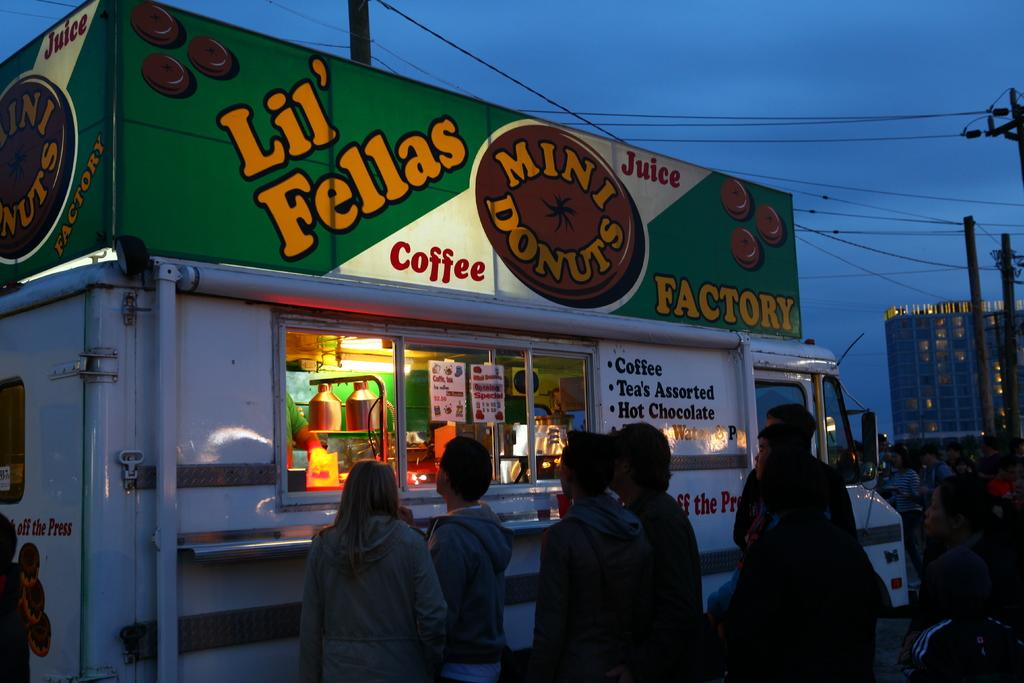How many people are in the group that is visible in the image? There is a group of people standing in the image, but the exact number cannot be determined from the provided facts. What type of vehicle is in the image? There is a vehicle in the image, but the specific type cannot be determined from the provided facts. What are the banners and posters used for in the image? Banners and posters are present in the image, but their purpose cannot be determined from the provided facts. What are the cans used for in the image? Cans are in the image, but their purpose cannot be determined from the provided facts. What type of buildings are present in the image? Buildings are present in the image, but their specific type cannot be determined from the provided facts. What are the poles used for in the image? Poles are in the image, but their purpose cannot be determined from the provided facts. What are the wires used for in the image? Wires are visible in the image, but their purpose cannot be determined from the provided facts. What is visible in the background of the image? The sky is visible in the background of the image. What type of shoe is hanging from the wire in the image? There is no shoe hanging from the wire in the image; only wires are visible. What color is the hair of the person standing in the image? There is no information about the hair of any person in the image. 